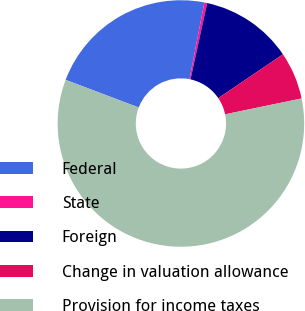<chart> <loc_0><loc_0><loc_500><loc_500><pie_chart><fcel>Federal<fcel>State<fcel>Foreign<fcel>Change in valuation allowance<fcel>Provision for income taxes<nl><fcel>22.29%<fcel>0.37%<fcel>12.1%<fcel>6.23%<fcel>59.01%<nl></chart> 